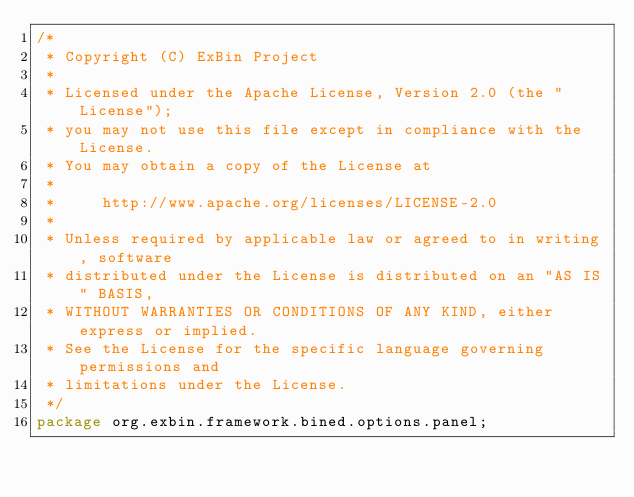Convert code to text. <code><loc_0><loc_0><loc_500><loc_500><_Java_>/*
 * Copyright (C) ExBin Project
 *
 * Licensed under the Apache License, Version 2.0 (the "License");
 * you may not use this file except in compliance with the License.
 * You may obtain a copy of the License at
 *
 *     http://www.apache.org/licenses/LICENSE-2.0
 *
 * Unless required by applicable law or agreed to in writing, software
 * distributed under the License is distributed on an "AS IS" BASIS,
 * WITHOUT WARRANTIES OR CONDITIONS OF ANY KIND, either express or implied.
 * See the License for the specific language governing permissions and
 * limitations under the License.
 */
package org.exbin.framework.bined.options.panel;
</code> 